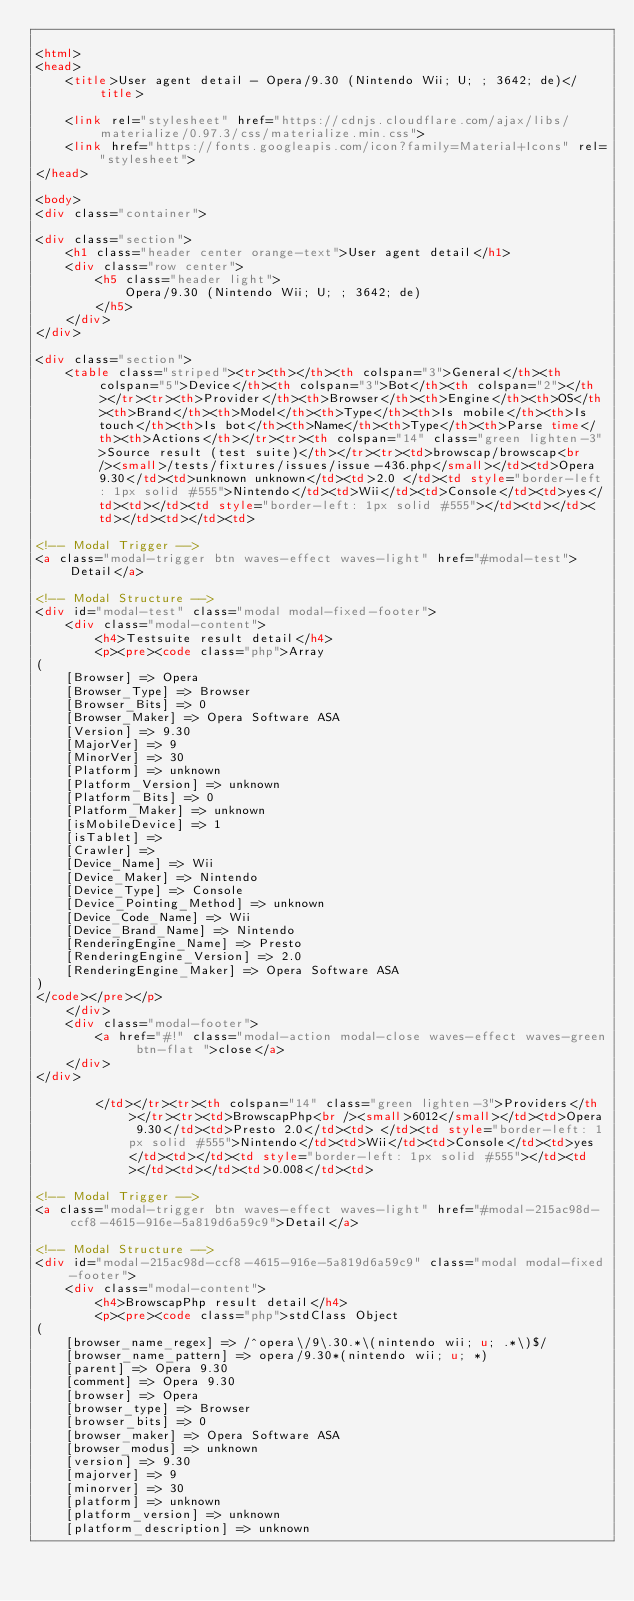Convert code to text. <code><loc_0><loc_0><loc_500><loc_500><_HTML_>
<html>
<head>
    <title>User agent detail - Opera/9.30 (Nintendo Wii; U; ; 3642; de)</title>
        
    <link rel="stylesheet" href="https://cdnjs.cloudflare.com/ajax/libs/materialize/0.97.3/css/materialize.min.css">
    <link href="https://fonts.googleapis.com/icon?family=Material+Icons" rel="stylesheet">
</head>
        
<body>
<div class="container">
    
<div class="section">
	<h1 class="header center orange-text">User agent detail</h1>
	<div class="row center">
        <h5 class="header light">
            Opera/9.30 (Nintendo Wii; U; ; 3642; de)
        </h5>
	</div>
</div>   

<div class="section">
    <table class="striped"><tr><th></th><th colspan="3">General</th><th colspan="5">Device</th><th colspan="3">Bot</th><th colspan="2"></th></tr><tr><th>Provider</th><th>Browser</th><th>Engine</th><th>OS</th><th>Brand</th><th>Model</th><th>Type</th><th>Is mobile</th><th>Is touch</th><th>Is bot</th><th>Name</th><th>Type</th><th>Parse time</th><th>Actions</th></tr><tr><th colspan="14" class="green lighten-3">Source result (test suite)</th></tr><tr><td>browscap/browscap<br /><small>/tests/fixtures/issues/issue-436.php</small></td><td>Opera 9.30</td><td>unknown unknown</td><td>2.0 </td><td style="border-left: 1px solid #555">Nintendo</td><td>Wii</td><td>Console</td><td>yes</td><td></td><td style="border-left: 1px solid #555"></td><td></td><td></td><td></td><td>
                
<!-- Modal Trigger -->
<a class="modal-trigger btn waves-effect waves-light" href="#modal-test">Detail</a>

<!-- Modal Structure -->
<div id="modal-test" class="modal modal-fixed-footer">
    <div class="modal-content">
        <h4>Testsuite result detail</h4>
        <p><pre><code class="php">Array
(
    [Browser] => Opera
    [Browser_Type] => Browser
    [Browser_Bits] => 0
    [Browser_Maker] => Opera Software ASA
    [Version] => 9.30
    [MajorVer] => 9
    [MinorVer] => 30
    [Platform] => unknown
    [Platform_Version] => unknown
    [Platform_Bits] => 0
    [Platform_Maker] => unknown
    [isMobileDevice] => 1
    [isTablet] => 
    [Crawler] => 
    [Device_Name] => Wii
    [Device_Maker] => Nintendo
    [Device_Type] => Console
    [Device_Pointing_Method] => unknown
    [Device_Code_Name] => Wii
    [Device_Brand_Name] => Nintendo
    [RenderingEngine_Name] => Presto
    [RenderingEngine_Version] => 2.0
    [RenderingEngine_Maker] => Opera Software ASA
)
</code></pre></p>
    </div>
    <div class="modal-footer">
        <a href="#!" class="modal-action modal-close waves-effect waves-green btn-flat ">close</a>
    </div>
</div>
                
        </td></tr><tr><th colspan="14" class="green lighten-3">Providers</th></tr><tr><td>BrowscapPhp<br /><small>6012</small></td><td>Opera 9.30</td><td>Presto 2.0</td><td> </td><td style="border-left: 1px solid #555">Nintendo</td><td>Wii</td><td>Console</td><td>yes</td><td></td><td style="border-left: 1px solid #555"></td><td></td><td></td><td>0.008</td><td>
                
<!-- Modal Trigger -->
<a class="modal-trigger btn waves-effect waves-light" href="#modal-215ac98d-ccf8-4615-916e-5a819d6a59c9">Detail</a>

<!-- Modal Structure -->
<div id="modal-215ac98d-ccf8-4615-916e-5a819d6a59c9" class="modal modal-fixed-footer">
    <div class="modal-content">
        <h4>BrowscapPhp result detail</h4>
        <p><pre><code class="php">stdClass Object
(
    [browser_name_regex] => /^opera\/9\.30.*\(nintendo wii; u; .*\)$/
    [browser_name_pattern] => opera/9.30*(nintendo wii; u; *)
    [parent] => Opera 9.30
    [comment] => Opera 9.30
    [browser] => Opera
    [browser_type] => Browser
    [browser_bits] => 0
    [browser_maker] => Opera Software ASA
    [browser_modus] => unknown
    [version] => 9.30
    [majorver] => 9
    [minorver] => 30
    [platform] => unknown
    [platform_version] => unknown
    [platform_description] => unknown</code> 